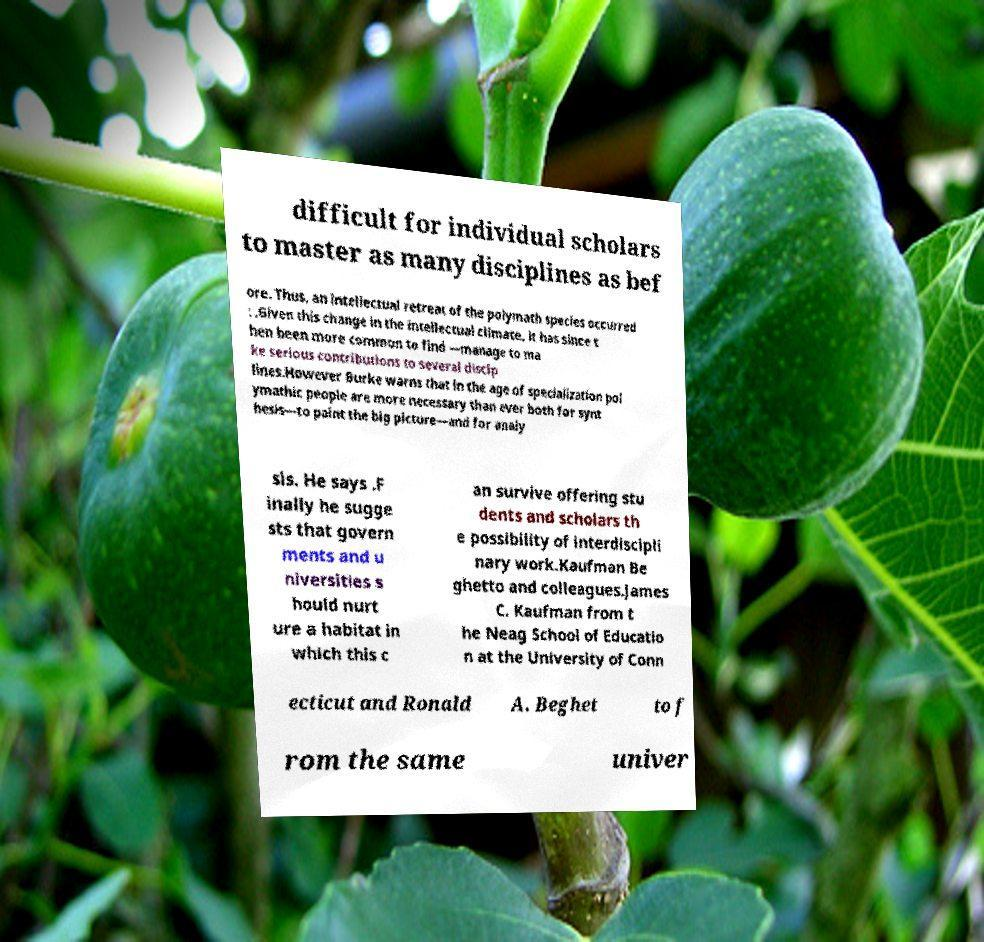Please identify and transcribe the text found in this image. difficult for individual scholars to master as many disciplines as bef ore. Thus, an intellectual retreat of the polymath species occurred : .Given this change in the intellectual climate, it has since t hen been more common to find —manage to ma ke serious contributions to several discip lines.However Burke warns that in the age of specialization pol ymathic people are more necessary than ever both for synt hesis—to paint the big picture—and for analy sis. He says .F inally he sugge sts that govern ments and u niversities s hould nurt ure a habitat in which this c an survive offering stu dents and scholars th e possibility of interdiscipli nary work.Kaufman Be ghetto and colleagues.James C. Kaufman from t he Neag School of Educatio n at the University of Conn ecticut and Ronald A. Beghet to f rom the same univer 